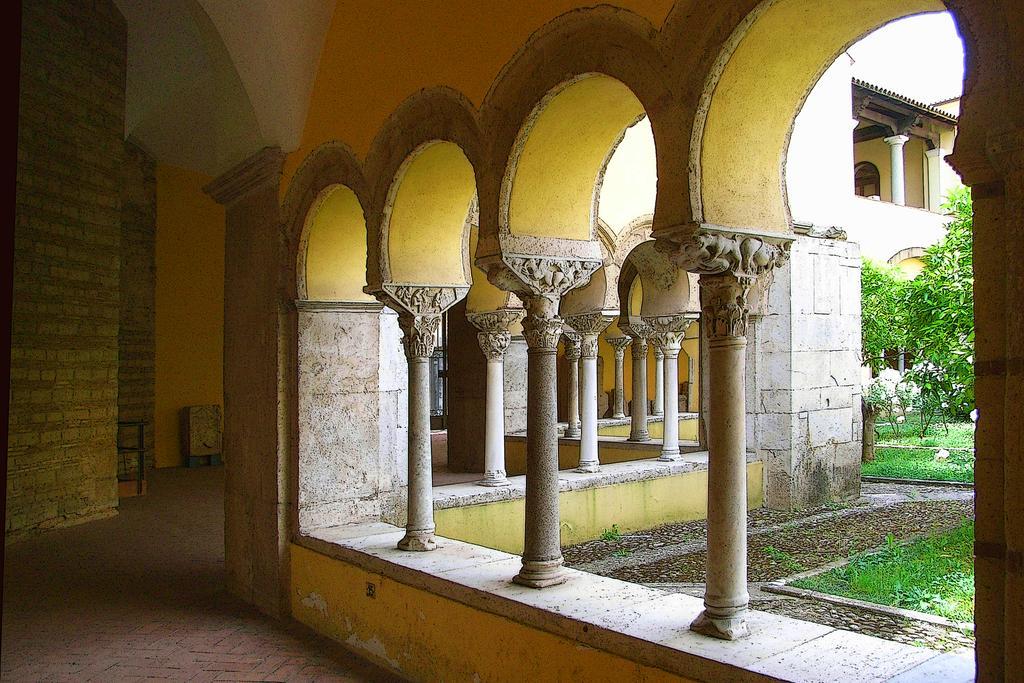Could you give a brief overview of what you see in this image? In this image I can see a building , in front of building there are trees visible on the right side. 